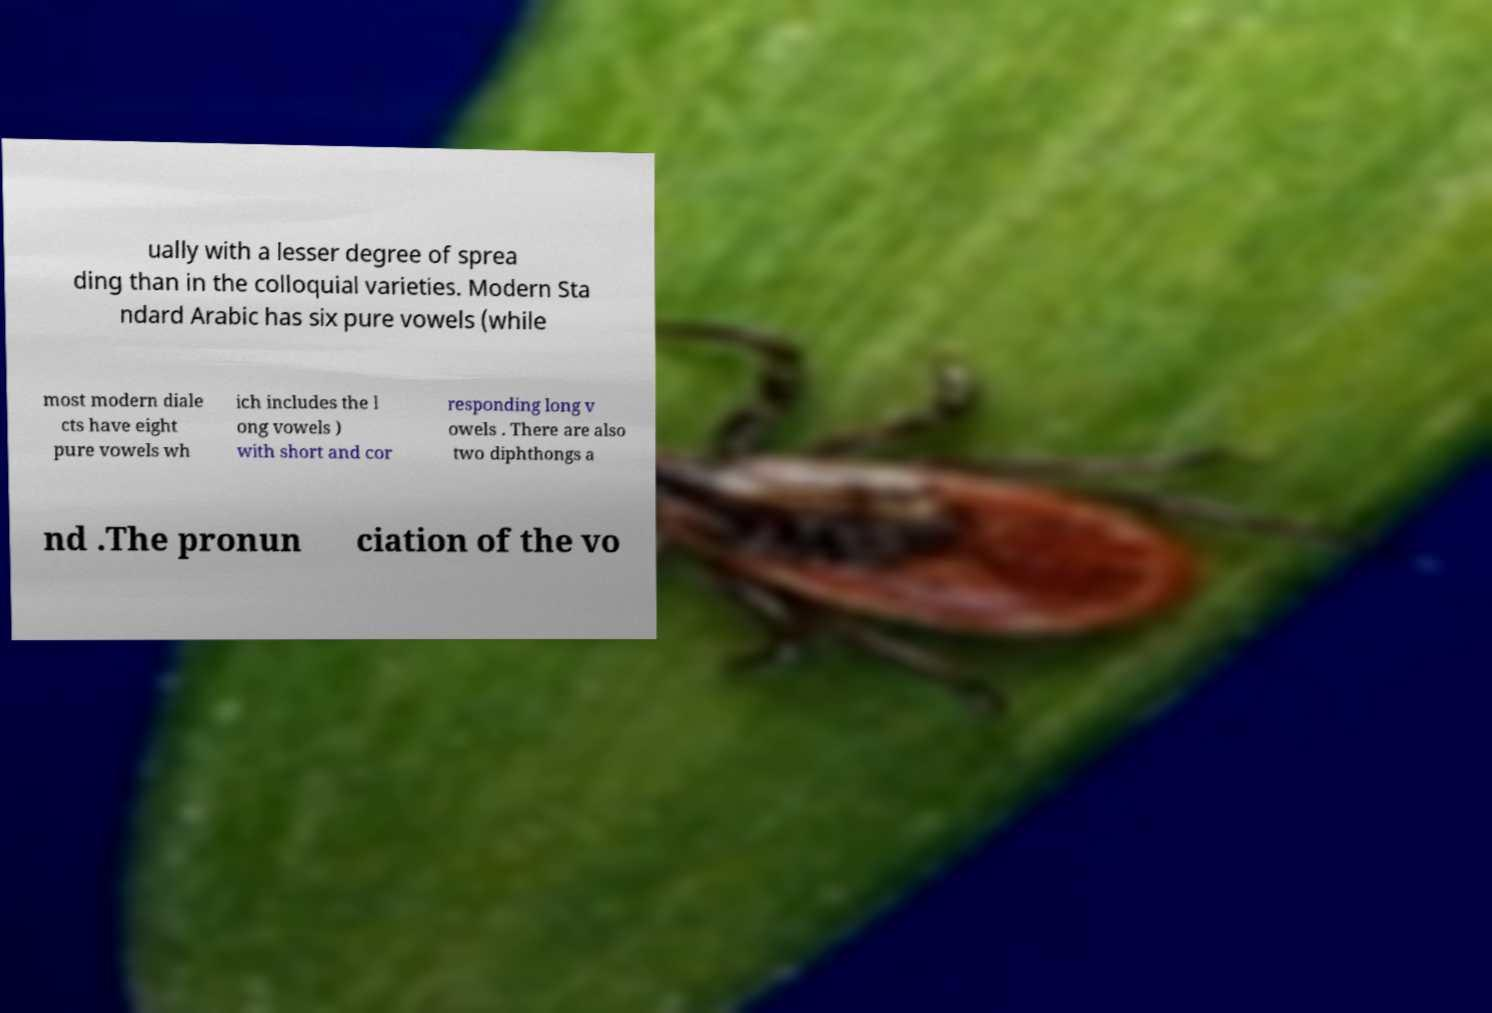Could you assist in decoding the text presented in this image and type it out clearly? ually with a lesser degree of sprea ding than in the colloquial varieties. Modern Sta ndard Arabic has six pure vowels (while most modern diale cts have eight pure vowels wh ich includes the l ong vowels ) with short and cor responding long v owels . There are also two diphthongs a nd .The pronun ciation of the vo 